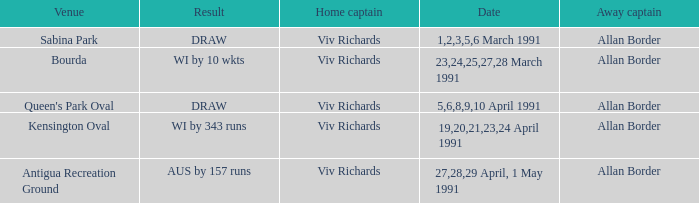What dates contained matches at the venue Bourda? 23,24,25,27,28 March 1991. 